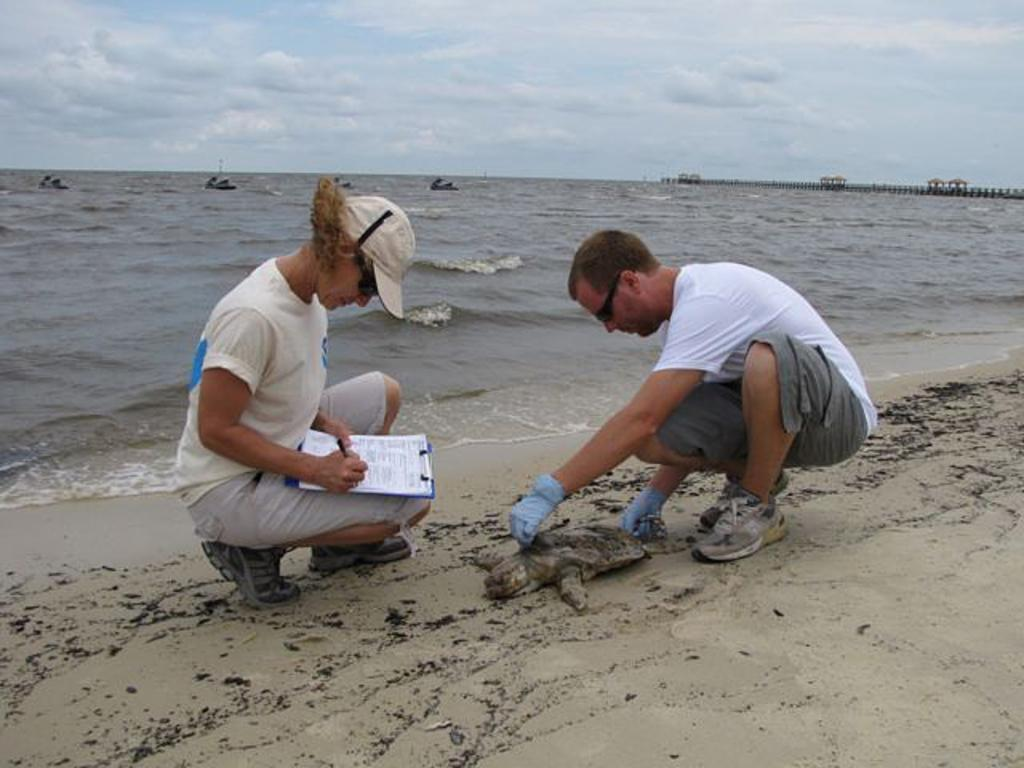How many people are wearing glasses in the image? There are two people wearing glasses in the image. What is one of the people holding in the image? One person is holding a pad with papers. What can be seen in the background of the image? There is a sea visible in the background of the image. What is visible at the top of the image? The sky is visible at the top of the image. What type of dolls can be seen playing during recess in the image? There are no dolls or any indication of a recess in the image; it features two people wearing glasses and a sea in the background. 